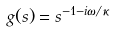<formula> <loc_0><loc_0><loc_500><loc_500>g ( s ) = s ^ { - 1 - i \omega / \kappa }</formula> 